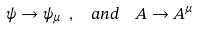<formula> <loc_0><loc_0><loc_500><loc_500>\psi \to \psi _ { \mu } \ , \ \ { a n d } \ \ A \to A ^ { \mu }</formula> 